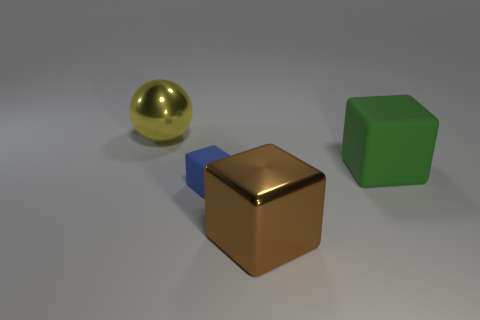How would you describe the lighting and shadows in the scene? The lighting in the scene is soft and diffused, with a source that seems to be above and slightly in front of the objects, casting gentle shadows behind them. This creates a calm and even atmosphere, highlighting the shapes and textures of the objects. 